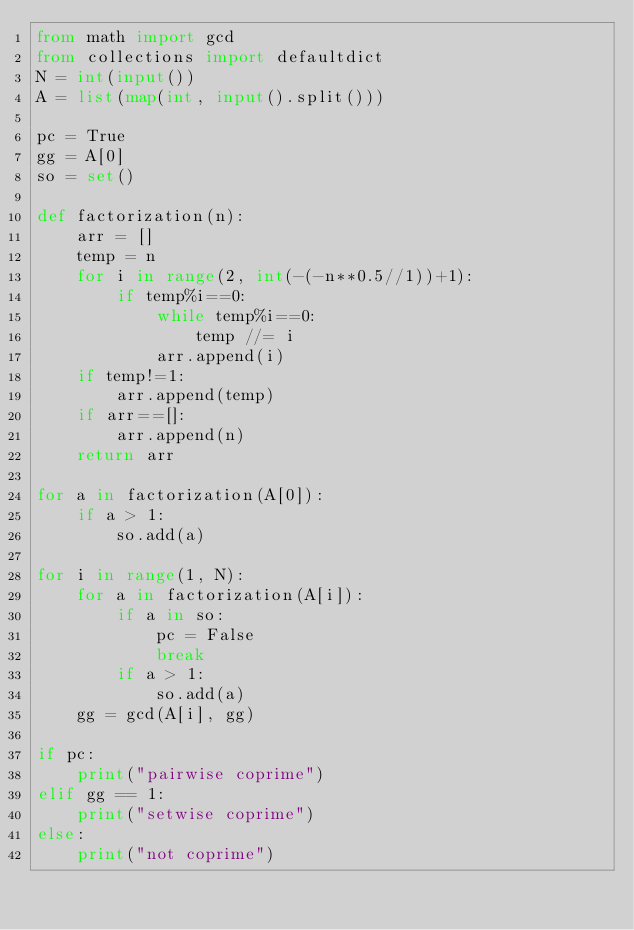<code> <loc_0><loc_0><loc_500><loc_500><_Python_>from math import gcd
from collections import defaultdict
N = int(input())
A = list(map(int, input().split()))

pc = True
gg = A[0]
so = set()

def factorization(n):
    arr = []
    temp = n
    for i in range(2, int(-(-n**0.5//1))+1):
        if temp%i==0:
            while temp%i==0:
                temp //= i
            arr.append(i)
    if temp!=1:
        arr.append(temp)
    if arr==[]:
        arr.append(n)
    return arr

for a in factorization(A[0]):
    if a > 1:
        so.add(a)

for i in range(1, N):
    for a in factorization(A[i]):
        if a in so:
            pc = False
            break
        if a > 1:
            so.add(a)
    gg = gcd(A[i], gg)

if pc:
    print("pairwise coprime")
elif gg == 1:
    print("setwise coprime")
else:
    print("not coprime")</code> 